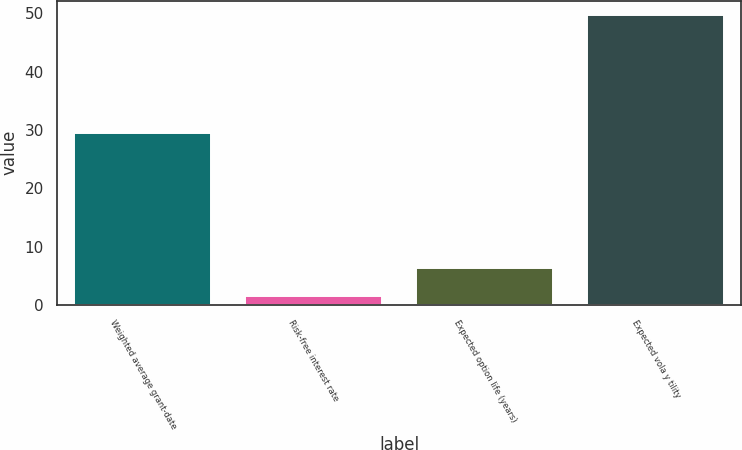Convert chart. <chart><loc_0><loc_0><loc_500><loc_500><bar_chart><fcel>Weighted average grant-date<fcel>Risk-free interest rate<fcel>Expected option life (years)<fcel>Expected vola y tility<nl><fcel>29.57<fcel>1.55<fcel>6.37<fcel>49.7<nl></chart> 